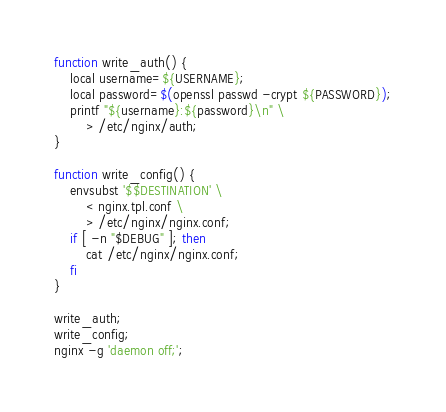Convert code to text. <code><loc_0><loc_0><loc_500><loc_500><_Bash_>function write_auth() {
    local username=${USERNAME};
    local password=$(openssl passwd -crypt ${PASSWORD});
    printf "${username}:${password}\n" \
        > /etc/nginx/auth;
}

function write_config() {
    envsubst '$$DESTINATION' \
        < nginx.tpl.conf \
        > /etc/nginx/nginx.conf;
    if [ -n "$DEBUG" ]; then
        cat /etc/nginx/nginx.conf;
    fi
}

write_auth;
write_config;
nginx -g 'daemon off;';
</code> 